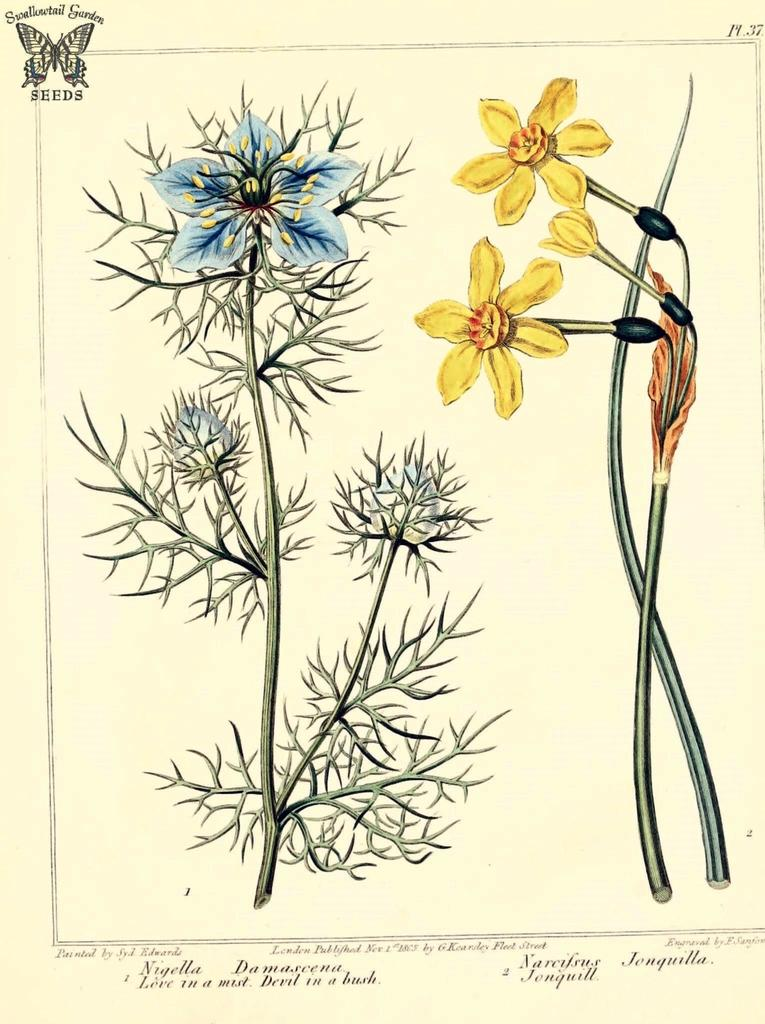How many flowers are present in the image? There are two flowers in the image. What colors are the flowers? One flower is blue, and the other is yellow. What is written below the flowers? There is text written below the flowers. Is there a drum being played by the flowers in the image? No, there is no drum or any indication of music being played in the image. 